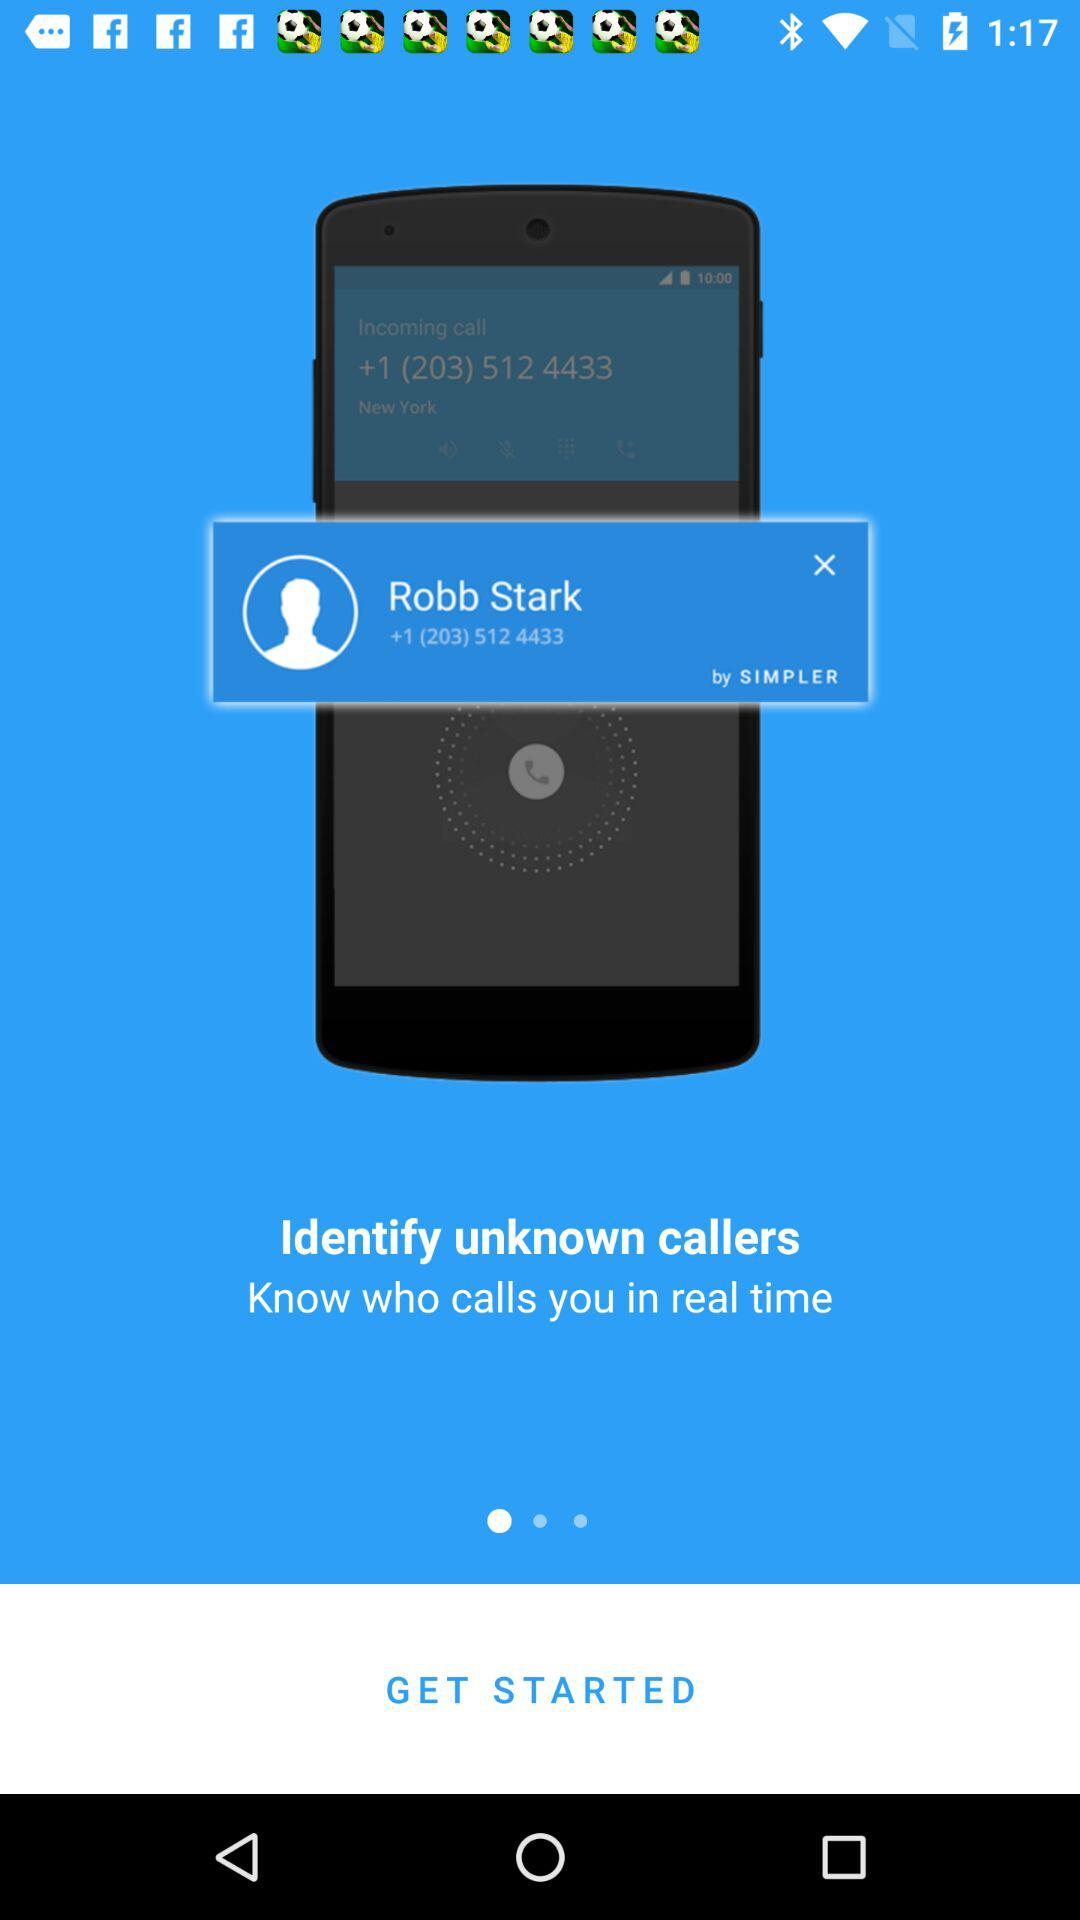What is the number shown on the app? The shown number is +1 (203) 512 4433. 